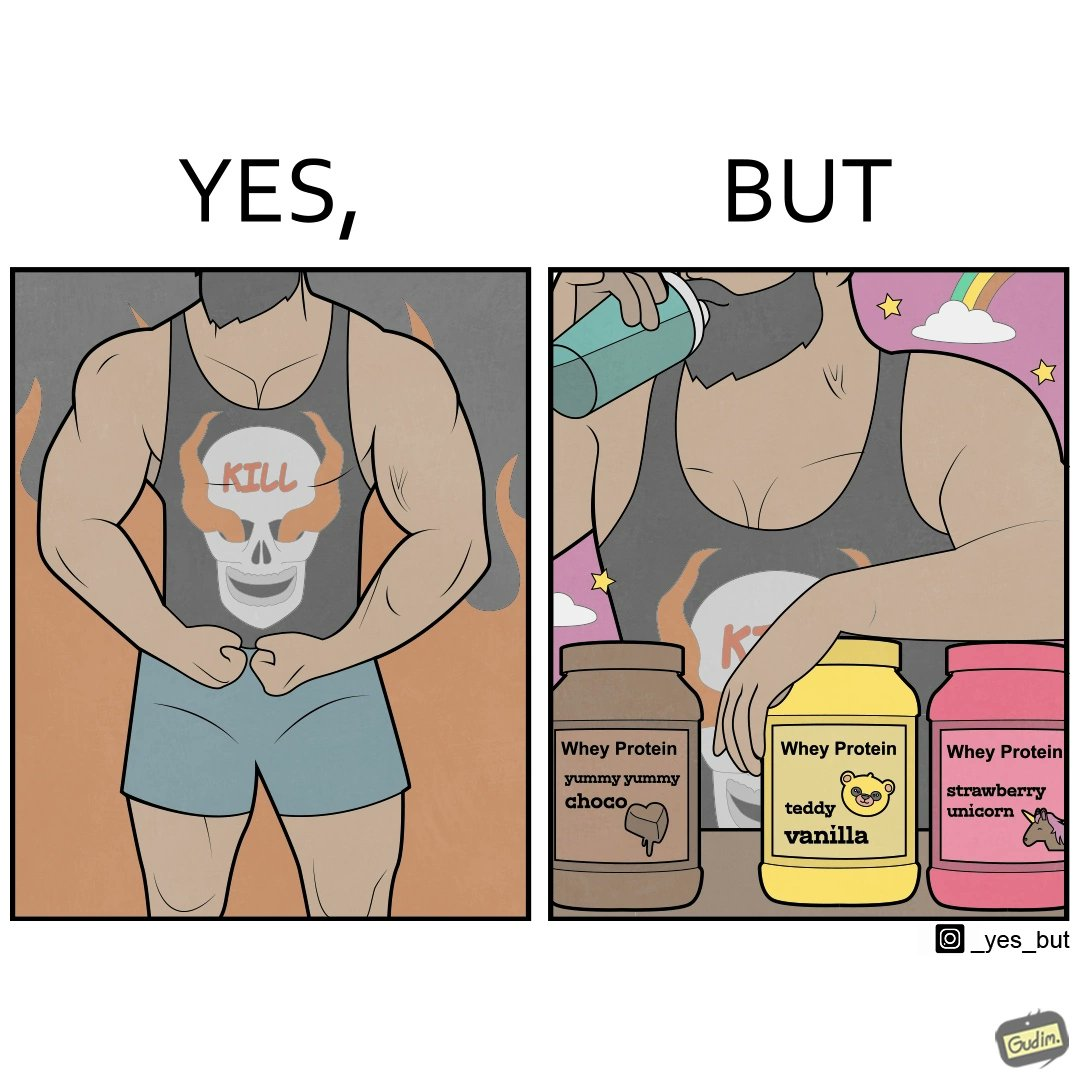Compare the left and right sides of this image. In the left part of the image: a well-built person wearing a tank top with the word "KILL" on an image of a skull. In the right part of the image: a well-built person consuming whey protein from one of three flavours. 